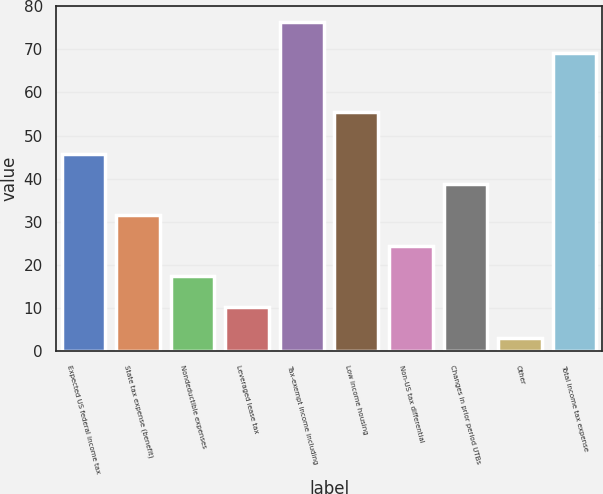Convert chart to OTSL. <chart><loc_0><loc_0><loc_500><loc_500><bar_chart><fcel>Expected US federal income tax<fcel>State tax expense (benefit)<fcel>Nondeductible expenses<fcel>Leveraged lease tax<fcel>Tax-exempt income including<fcel>Low income housing<fcel>Non-US tax differential<fcel>Changes in prior period UTBs<fcel>Other<fcel>Total income tax expense<nl><fcel>45.8<fcel>31.6<fcel>17.4<fcel>10.3<fcel>76.3<fcel>55.4<fcel>24.5<fcel>38.7<fcel>3.2<fcel>69.2<nl></chart> 